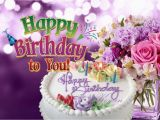I'm curious about the bouquet. What types of flowers can be seen? The bouquet in the image features an assortment of flowers, including blooms that resemble peonies, roses, and possibly lilacs or lavender. These flowers are depicted in shades of white, pink, light purple, and deep purple, creating a rich tapestry of color that beautifully complements the birthday theme. The bouquet as a whole adds a touch of natural beauty and sophistication to the image. 